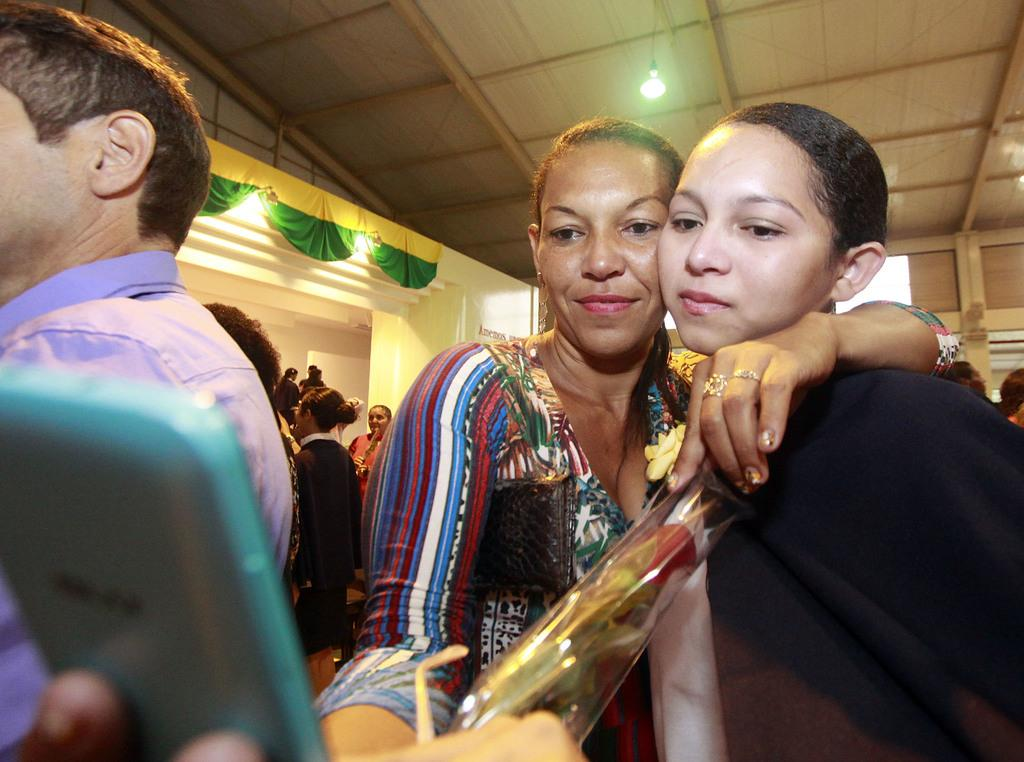What is the woman in the image doing with her hands? The woman is holding a mobile in one hand and another woman in her other hand. Can you describe the mobile the woman is holding? The facts do not provide a description of the mobile. What can be seen in the background of the image? There are other persons in the background of the image. What type of songs is the woman singing in the image? The facts do not mention any singing or songs in the image. 